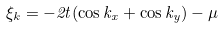Convert formula to latex. <formula><loc_0><loc_0><loc_500><loc_500>\xi _ { k } = - 2 t ( \cos k _ { x } + \cos k _ { y } ) - \mu</formula> 